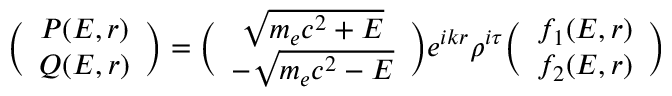<formula> <loc_0><loc_0><loc_500><loc_500>\left ( \begin{array} { c c } { P ( E , r ) } \\ { Q ( E , r ) } \end{array} \right ) = \left ( \begin{array} { c c } { \sqrt { m _ { e } c ^ { 2 } + E } } \\ { - \sqrt { m _ { e } c ^ { 2 } - E } } \end{array} \right ) e ^ { i k r } \rho ^ { i \tau } \left ( \begin{array} { c c } { f _ { 1 } ( E , r ) } \\ { f _ { 2 } ( E , r ) } \end{array} \right )</formula> 